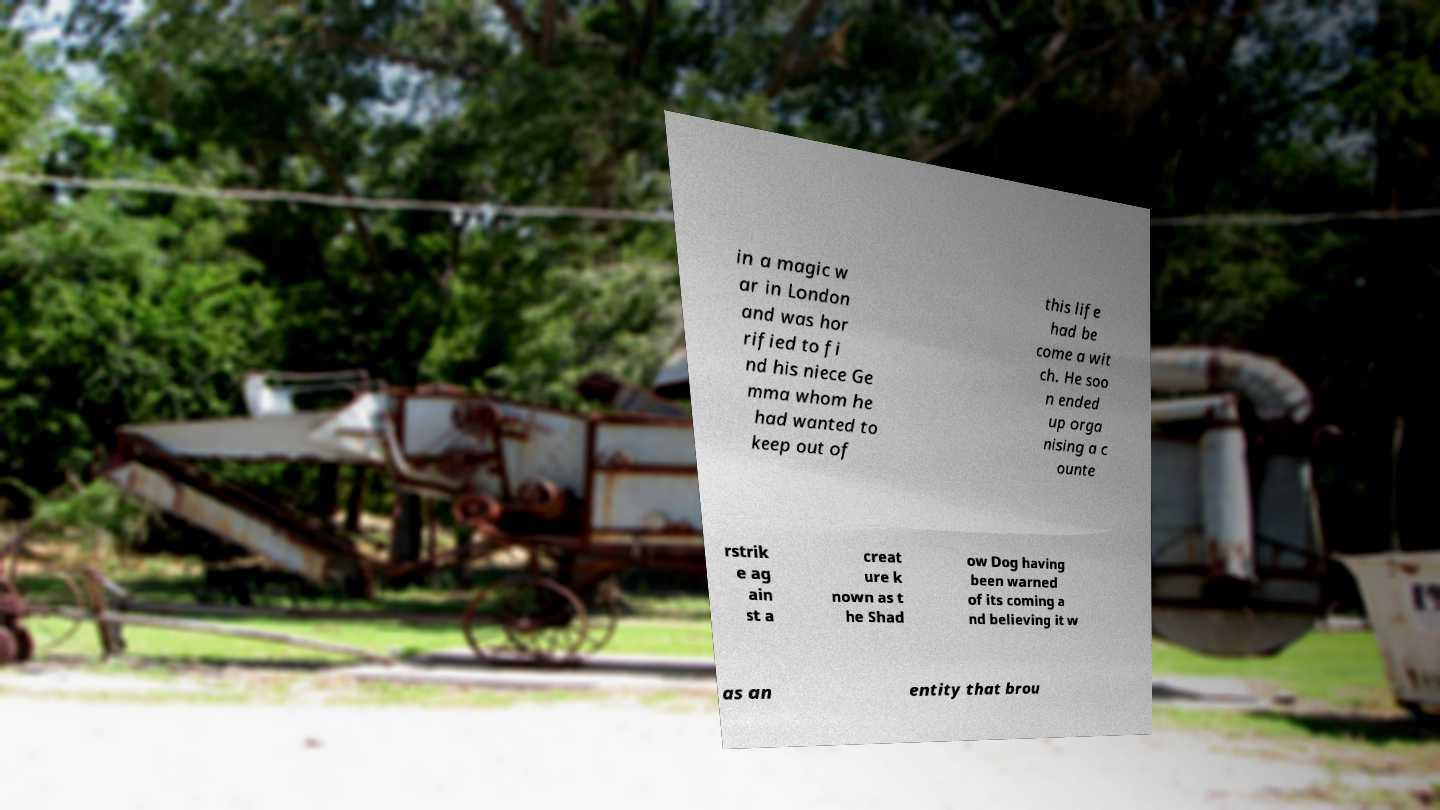Could you assist in decoding the text presented in this image and type it out clearly? in a magic w ar in London and was hor rified to fi nd his niece Ge mma whom he had wanted to keep out of this life had be come a wit ch. He soo n ended up orga nising a c ounte rstrik e ag ain st a creat ure k nown as t he Shad ow Dog having been warned of its coming a nd believing it w as an entity that brou 